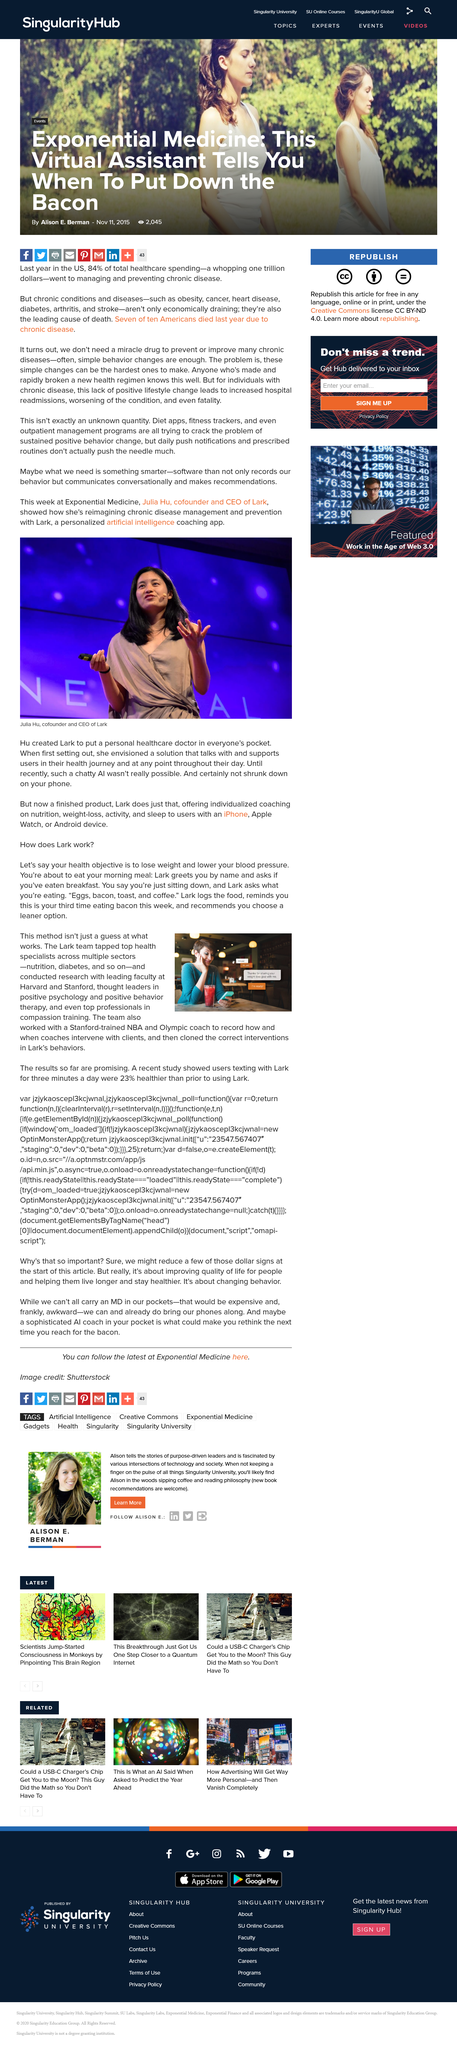Specify some key components in this picture. A weight loss goal was mentioned in the text. Lark is the name of the texting app that is being queried. Julia Hu is the co-founder and CEO of Lark. The first text message shown in the image is 'Hi Lisa'. Julia reimagined chronic disease management and prevention by using Lark, a personalized artificial intelligence coaching app, to achieve this goal. 